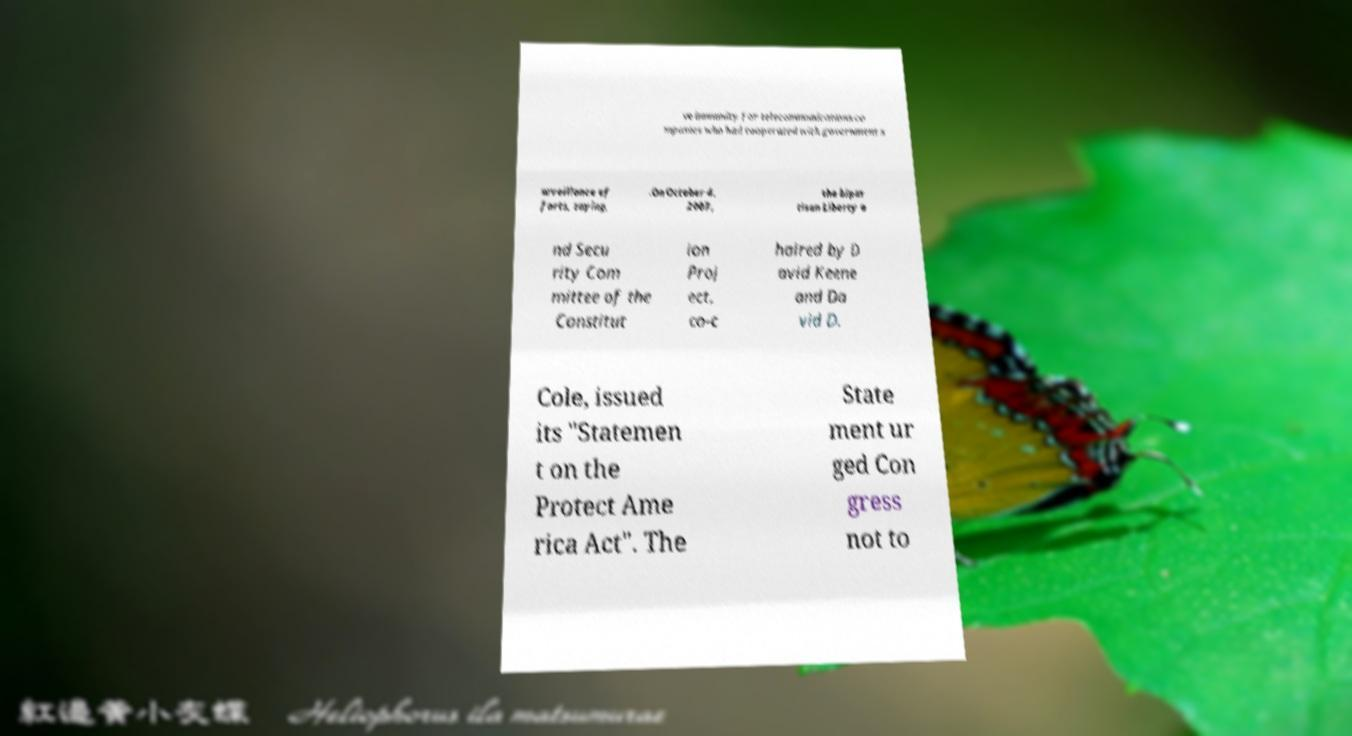I need the written content from this picture converted into text. Can you do that? ve immunity for telecommunications co mpanies who had cooperated with government s urveillance ef forts, saying, .On October 4, 2007, the bipar tisan Liberty a nd Secu rity Com mittee of the Constitut ion Proj ect, co-c haired by D avid Keene and Da vid D. Cole, issued its "Statemen t on the Protect Ame rica Act". The State ment ur ged Con gress not to 